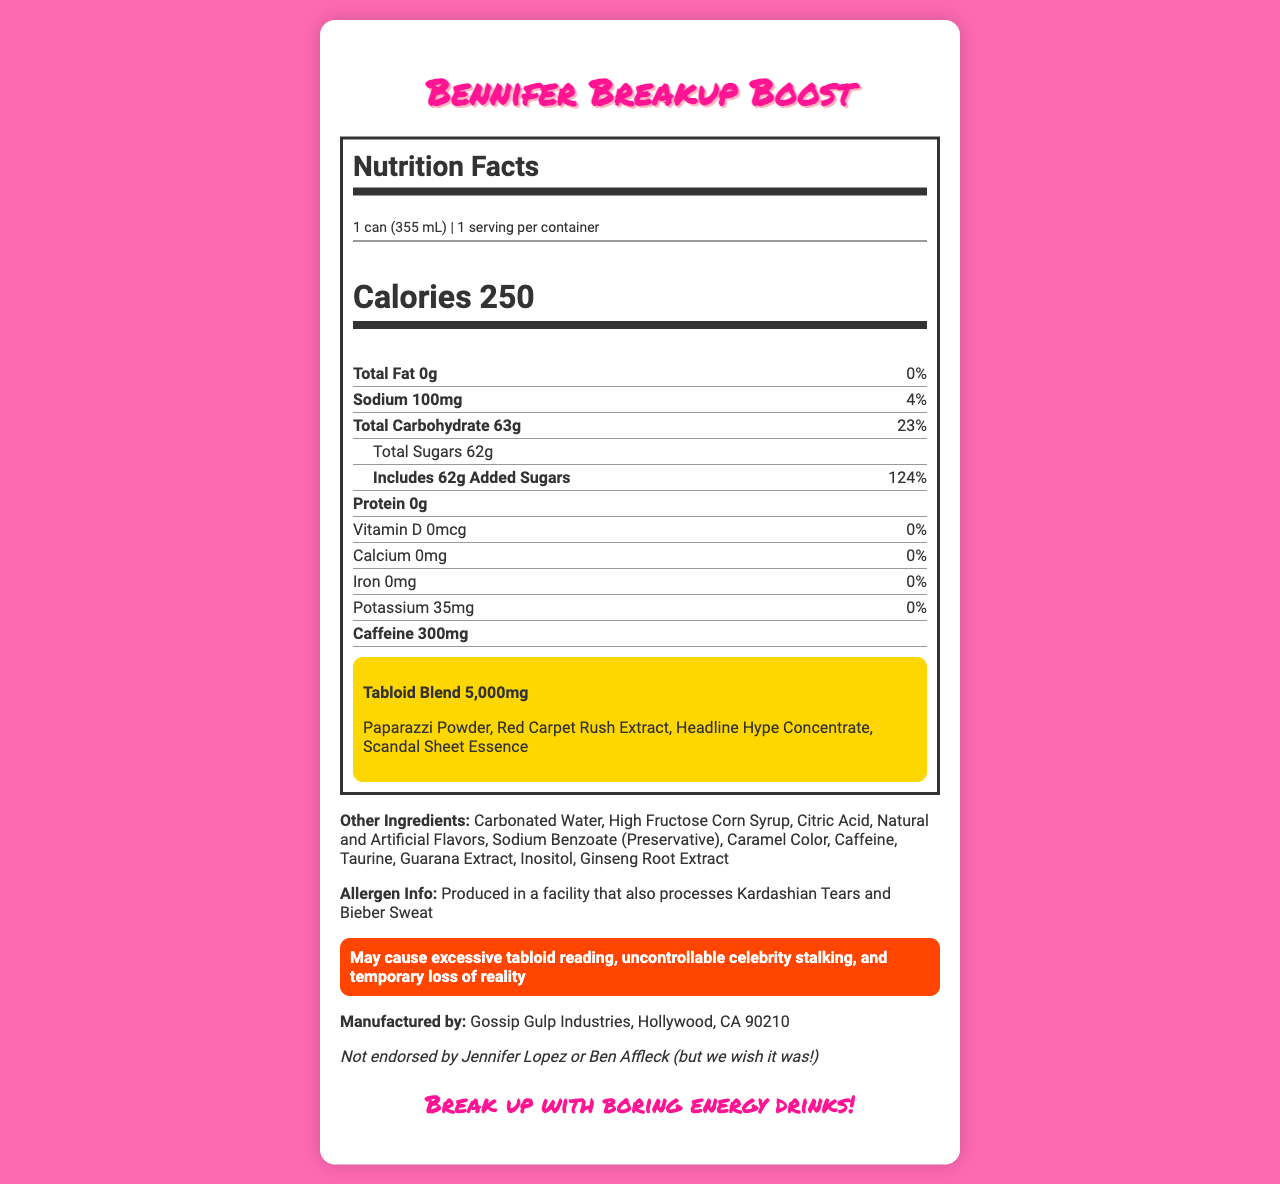what is the serving size? The serving size is listed at the top of the Nutrition Facts section as "1 can (355 mL)".
Answer: 1 can (355 mL) How many calories are in one serving? The number of calories per serving is prominently displayed right below the serving size as "Calories 250".
Answer: 250 calories what is the total carbohydrate content? The total carbohydrate content is indicated right after the sodium content as "Total Carbohydrate 63g 23%".
Answer: 63g which ingredient has the highest daily value percentage for added sugars? The added sugars have the highest daily value percentage, indicated as "Includes 62g Added Sugars" with "124%" next to it.
Answer: 62g what is the caffeine content of this drink? The caffeine content is listed towards the bottom of the Nutrition Facts as "Caffeine 300mg".
Answer: 300mg How much sodium is in one serving? A. 50mg B. 100mg C. 150mg D. 200mg The sodium content is listed as "Sodium 100mg" with a daily value of "4%" next to it.
Answer: B. 100mg which of the following is not included in the Tabloid Blend? A. Paparazzi Powder B. Red Carpet Rush Extract C. Headline Hype Concentrate D. Celebrity Buzz The Tabloid Blend includes "Paparazzi Powder, Red Carpet Rush Extract, Headline Hype Concentrate, Scandal Sheet Essence" but not "Celebrity Buzz".
Answer: D. Celebrity Buzz is this product endorsed by Jennifer Lopez or Ben Affleck? It specifically states "Not endorsed by Jennifer Lopez or Ben Affleck" in a lighter font towards the bottom of the document.
Answer: No does the drink contain any protein? The document explicitly mentions "Protein 0g".
Answer: No summarize the main idea of this document. The document includes nutritional information such as serving size, calories, total fat, sodium, carbohydrates, sugars, and caffeine content. It also lists special ingredients under the Tabloid Blend and other ingredients, along with allergen information and a humorous warning about possible side effects.
Answer: The document is a detailed Nutrition Facts label for an energy drink called "Bennifer Breakup Boost", listing its nutritional content, ingredients, and some humorous warnings and endorsements. which vitamins or minerals are present in this drink? The drink has 0% daily value for Vitamin D, Calcium, Iron, and Potassium, as indicated in the nutrient section.
Answer: None who is the manufacturer of this energy drink? The manufacturer is mentioned towards the bottom as "Manufactured by: Gossip Gulp Industries, Hollywood, CA 90210".
Answer: Gossip Gulp Industries, Hollywood, CA 90210 What is the tagline or slogan for this energy drink? The slogan appears towards the bottom in a stylish font as "Break up with boring energy drinks!".
Answer: Break up with boring energy drinks! What is "Paparazzi Powder"? The document mentions "Paparazzi Powder" as part of the Tabloid Blend but does not provide further details about what it is.
Answer: Not enough information 